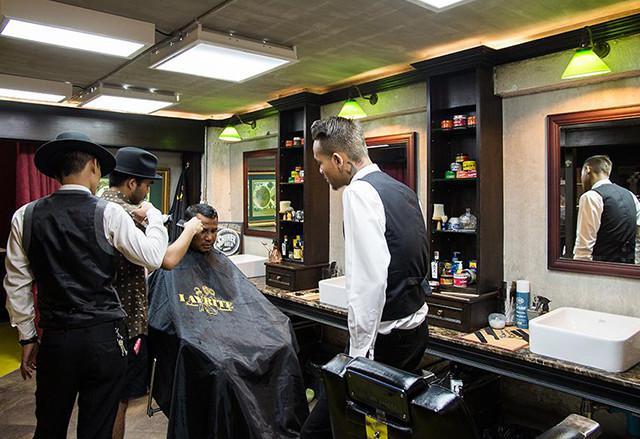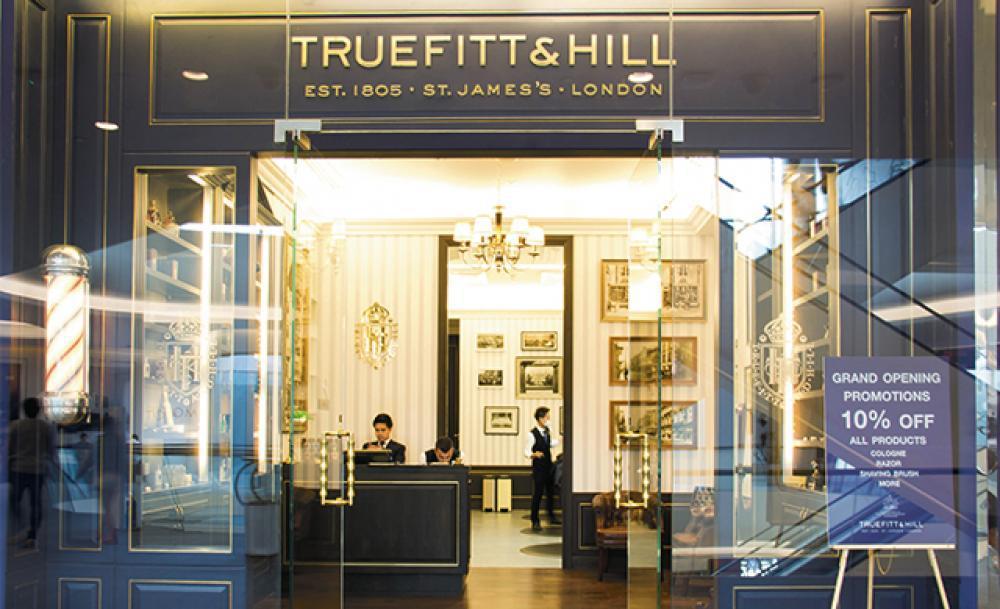The first image is the image on the left, the second image is the image on the right. Evaluate the accuracy of this statement regarding the images: "There are men in black vests working on a customer in a barber chair.". Is it true? Answer yes or no. Yes. 